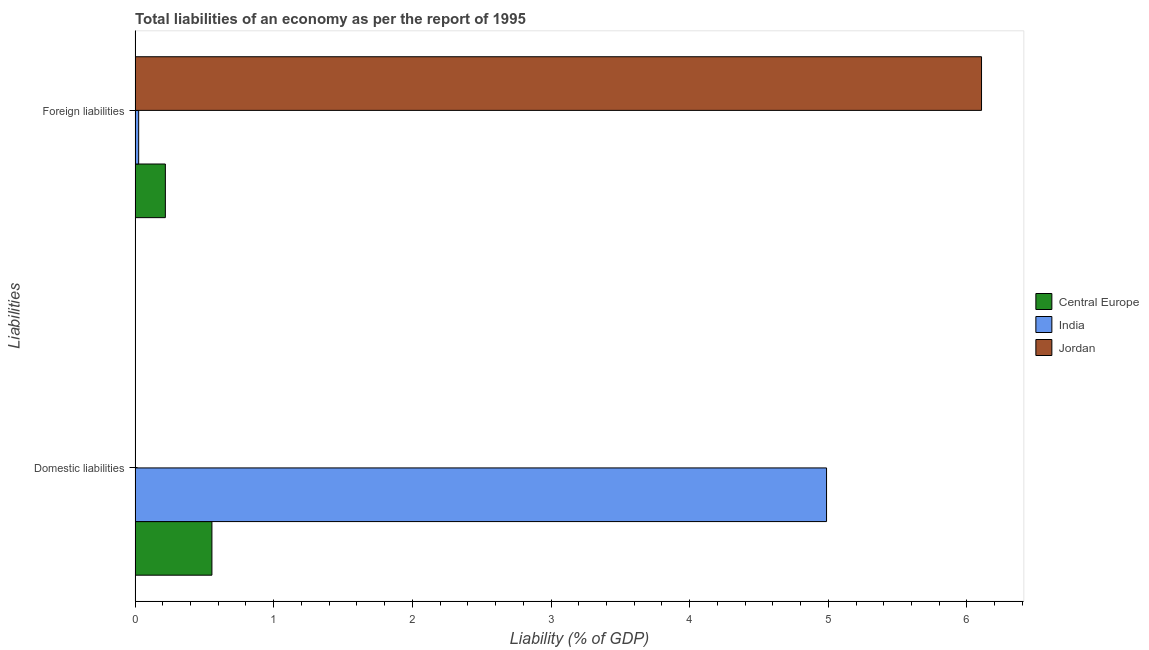How many groups of bars are there?
Provide a succinct answer. 2. What is the label of the 2nd group of bars from the top?
Offer a very short reply. Domestic liabilities. What is the incurrence of foreign liabilities in Jordan?
Make the answer very short. 6.11. Across all countries, what is the maximum incurrence of domestic liabilities?
Offer a very short reply. 4.99. Across all countries, what is the minimum incurrence of foreign liabilities?
Your response must be concise. 0.03. In which country was the incurrence of foreign liabilities maximum?
Make the answer very short. Jordan. What is the total incurrence of domestic liabilities in the graph?
Give a very brief answer. 5.54. What is the difference between the incurrence of foreign liabilities in Jordan and that in Central Europe?
Provide a succinct answer. 5.89. What is the difference between the incurrence of domestic liabilities in India and the incurrence of foreign liabilities in Jordan?
Your response must be concise. -1.12. What is the average incurrence of domestic liabilities per country?
Offer a terse response. 1.85. What is the difference between the incurrence of foreign liabilities and incurrence of domestic liabilities in Central Europe?
Offer a terse response. -0.34. In how many countries, is the incurrence of foreign liabilities greater than 5.2 %?
Provide a succinct answer. 1. What is the ratio of the incurrence of foreign liabilities in Jordan to that in Central Europe?
Make the answer very short. 27.95. How many bars are there?
Provide a short and direct response. 5. Are all the bars in the graph horizontal?
Provide a succinct answer. Yes. What is the difference between two consecutive major ticks on the X-axis?
Offer a very short reply. 1. Are the values on the major ticks of X-axis written in scientific E-notation?
Give a very brief answer. No. Does the graph contain grids?
Your answer should be very brief. No. How are the legend labels stacked?
Give a very brief answer. Vertical. What is the title of the graph?
Ensure brevity in your answer.  Total liabilities of an economy as per the report of 1995. Does "Liechtenstein" appear as one of the legend labels in the graph?
Ensure brevity in your answer.  No. What is the label or title of the X-axis?
Keep it short and to the point. Liability (% of GDP). What is the label or title of the Y-axis?
Offer a very short reply. Liabilities. What is the Liability (% of GDP) in Central Europe in Domestic liabilities?
Keep it short and to the point. 0.55. What is the Liability (% of GDP) in India in Domestic liabilities?
Keep it short and to the point. 4.99. What is the Liability (% of GDP) of Central Europe in Foreign liabilities?
Ensure brevity in your answer.  0.22. What is the Liability (% of GDP) in India in Foreign liabilities?
Provide a short and direct response. 0.03. What is the Liability (% of GDP) of Jordan in Foreign liabilities?
Provide a succinct answer. 6.11. Across all Liabilities, what is the maximum Liability (% of GDP) in Central Europe?
Your answer should be compact. 0.55. Across all Liabilities, what is the maximum Liability (% of GDP) of India?
Offer a very short reply. 4.99. Across all Liabilities, what is the maximum Liability (% of GDP) of Jordan?
Provide a succinct answer. 6.11. Across all Liabilities, what is the minimum Liability (% of GDP) in Central Europe?
Your response must be concise. 0.22. Across all Liabilities, what is the minimum Liability (% of GDP) of India?
Provide a succinct answer. 0.03. Across all Liabilities, what is the minimum Liability (% of GDP) of Jordan?
Offer a very short reply. 0. What is the total Liability (% of GDP) in Central Europe in the graph?
Your response must be concise. 0.77. What is the total Liability (% of GDP) of India in the graph?
Provide a succinct answer. 5.01. What is the total Liability (% of GDP) in Jordan in the graph?
Keep it short and to the point. 6.11. What is the difference between the Liability (% of GDP) in Central Europe in Domestic liabilities and that in Foreign liabilities?
Your answer should be compact. 0.34. What is the difference between the Liability (% of GDP) in India in Domestic liabilities and that in Foreign liabilities?
Keep it short and to the point. 4.96. What is the difference between the Liability (% of GDP) in Central Europe in Domestic liabilities and the Liability (% of GDP) in India in Foreign liabilities?
Make the answer very short. 0.53. What is the difference between the Liability (% of GDP) in Central Europe in Domestic liabilities and the Liability (% of GDP) in Jordan in Foreign liabilities?
Keep it short and to the point. -5.55. What is the difference between the Liability (% of GDP) in India in Domestic liabilities and the Liability (% of GDP) in Jordan in Foreign liabilities?
Keep it short and to the point. -1.12. What is the average Liability (% of GDP) in Central Europe per Liabilities?
Offer a very short reply. 0.39. What is the average Liability (% of GDP) of India per Liabilities?
Your response must be concise. 2.51. What is the average Liability (% of GDP) of Jordan per Liabilities?
Keep it short and to the point. 3.05. What is the difference between the Liability (% of GDP) of Central Europe and Liability (% of GDP) of India in Domestic liabilities?
Offer a very short reply. -4.43. What is the difference between the Liability (% of GDP) of Central Europe and Liability (% of GDP) of India in Foreign liabilities?
Provide a succinct answer. 0.19. What is the difference between the Liability (% of GDP) in Central Europe and Liability (% of GDP) in Jordan in Foreign liabilities?
Offer a very short reply. -5.89. What is the difference between the Liability (% of GDP) of India and Liability (% of GDP) of Jordan in Foreign liabilities?
Make the answer very short. -6.08. What is the ratio of the Liability (% of GDP) of Central Europe in Domestic liabilities to that in Foreign liabilities?
Keep it short and to the point. 2.54. What is the ratio of the Liability (% of GDP) of India in Domestic liabilities to that in Foreign liabilities?
Give a very brief answer. 191.2. What is the difference between the highest and the second highest Liability (% of GDP) of Central Europe?
Provide a succinct answer. 0.34. What is the difference between the highest and the second highest Liability (% of GDP) in India?
Keep it short and to the point. 4.96. What is the difference between the highest and the lowest Liability (% of GDP) of Central Europe?
Your response must be concise. 0.34. What is the difference between the highest and the lowest Liability (% of GDP) of India?
Offer a terse response. 4.96. What is the difference between the highest and the lowest Liability (% of GDP) in Jordan?
Offer a terse response. 6.11. 